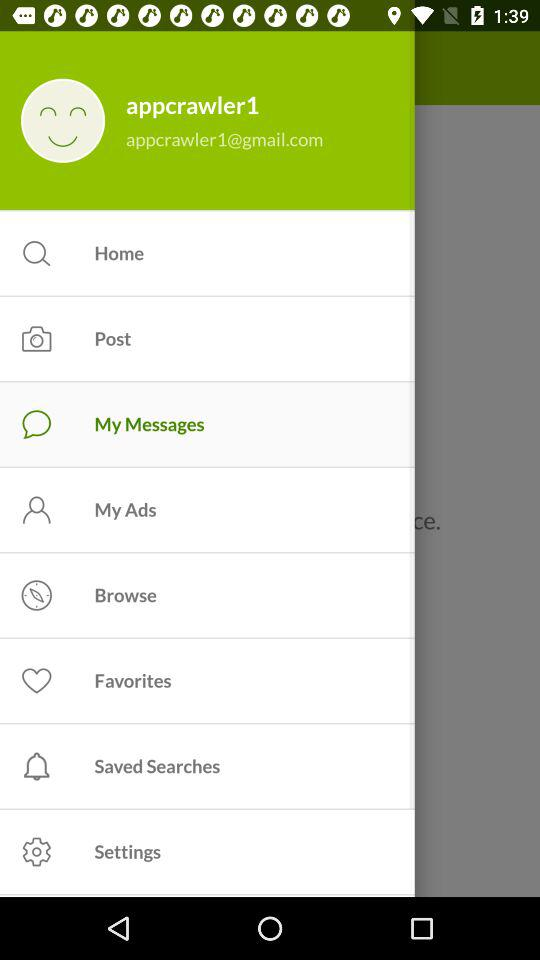Which item is selected? The selected item is "My Messages". 